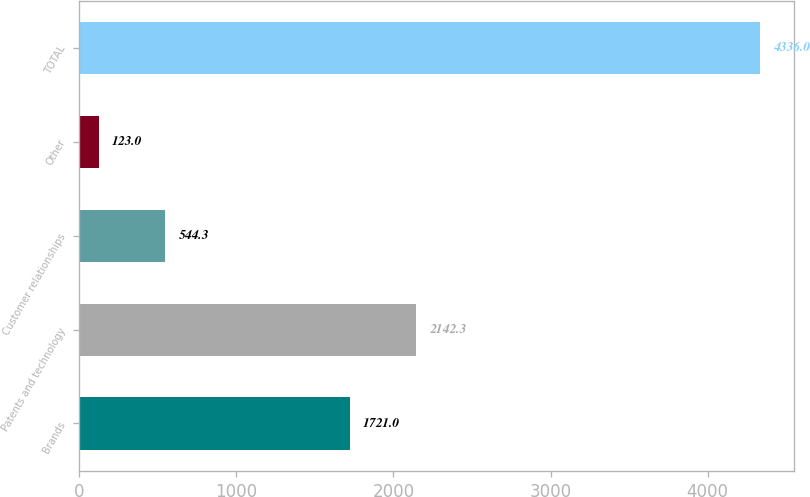Convert chart to OTSL. <chart><loc_0><loc_0><loc_500><loc_500><bar_chart><fcel>Brands<fcel>Patents and technology<fcel>Customer relationships<fcel>Other<fcel>TOTAL<nl><fcel>1721<fcel>2142.3<fcel>544.3<fcel>123<fcel>4336<nl></chart> 